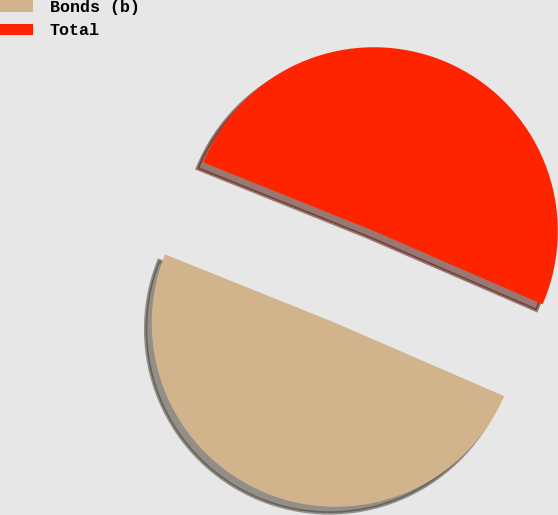Convert chart. <chart><loc_0><loc_0><loc_500><loc_500><pie_chart><fcel>Bonds (b)<fcel>Total<nl><fcel>49.57%<fcel>50.43%<nl></chart> 